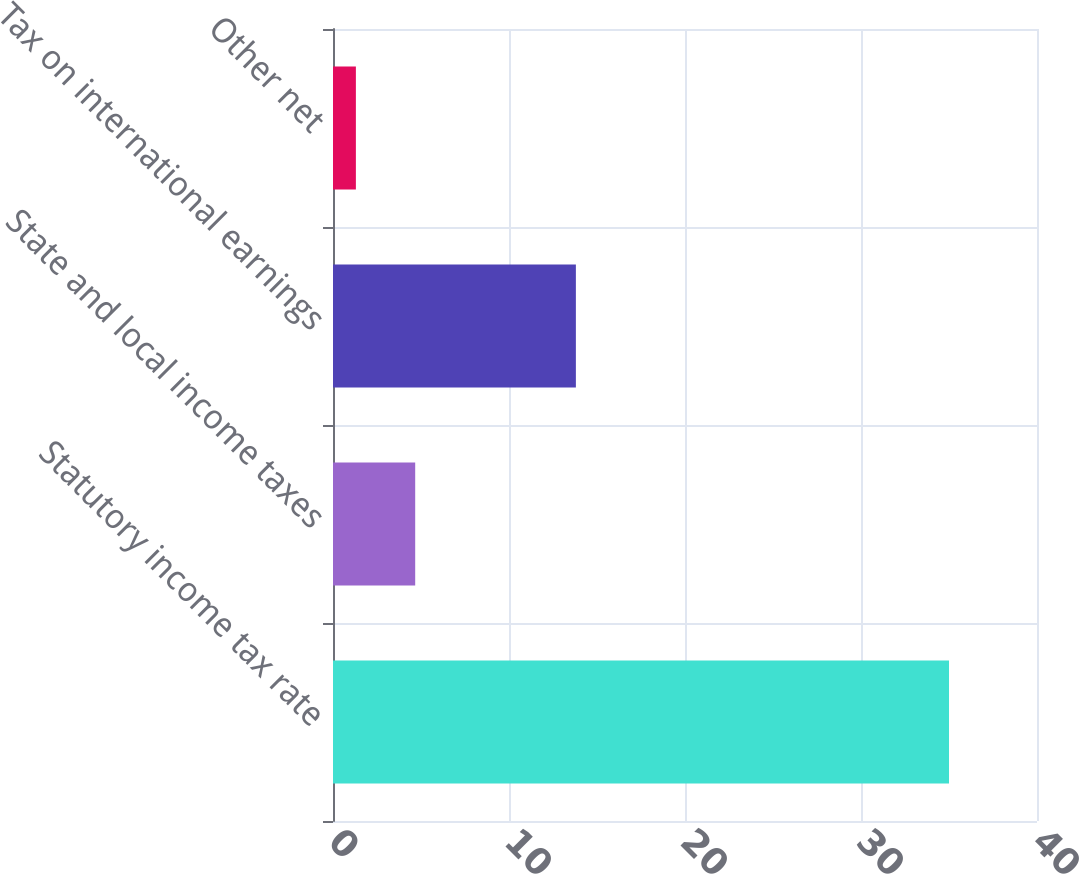<chart> <loc_0><loc_0><loc_500><loc_500><bar_chart><fcel>Statutory income tax rate<fcel>State and local income taxes<fcel>Tax on international earnings<fcel>Other net<nl><fcel>35<fcel>4.67<fcel>13.8<fcel>1.3<nl></chart> 